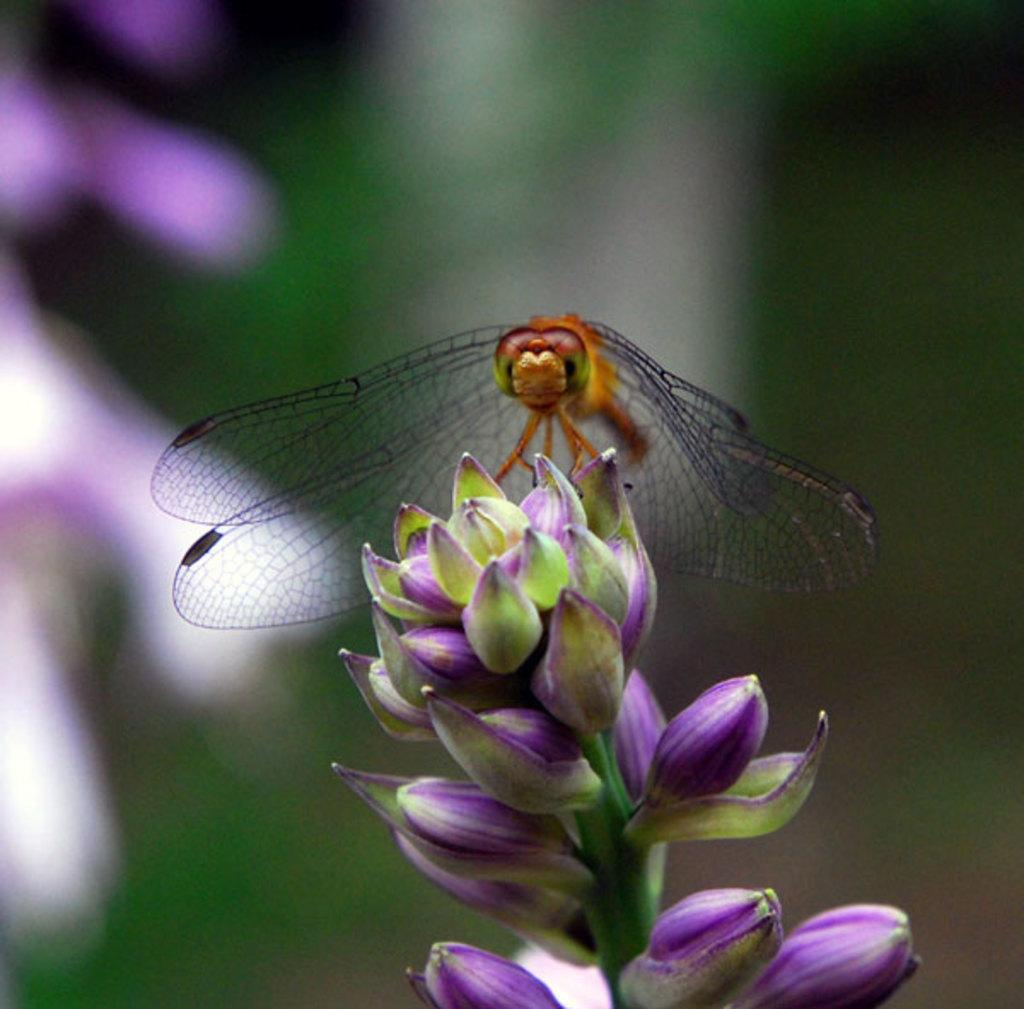What is the main subject of the image? There is a butterfly in the image. Where is the butterfly located? The butterfly is on a plant. Can you describe the background of the image? The background of the image is blurred. What color is the curtain behind the robin in the image? There is no robin or curtain present in the image. The main subject is a butterfly on a plant, and the background is blurred. 